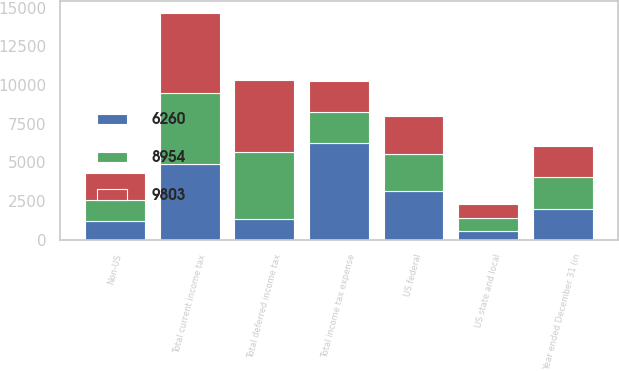<chart> <loc_0><loc_0><loc_500><loc_500><stacked_bar_chart><ecel><fcel>Year ended December 31 (in<fcel>US federal<fcel>Non-US<fcel>US state and local<fcel>Total current income tax<fcel>Total deferred income tax<fcel>Total income tax expense<nl><fcel>9803<fcel>2016<fcel>2488<fcel>1760<fcel>904<fcel>5152<fcel>4651<fcel>2016<nl><fcel>6260<fcel>2015<fcel>3160<fcel>1220<fcel>547<fcel>4927<fcel>1333<fcel>6260<nl><fcel>8954<fcel>2014<fcel>2382<fcel>1353<fcel>857<fcel>4592<fcel>4362<fcel>2016<nl></chart> 